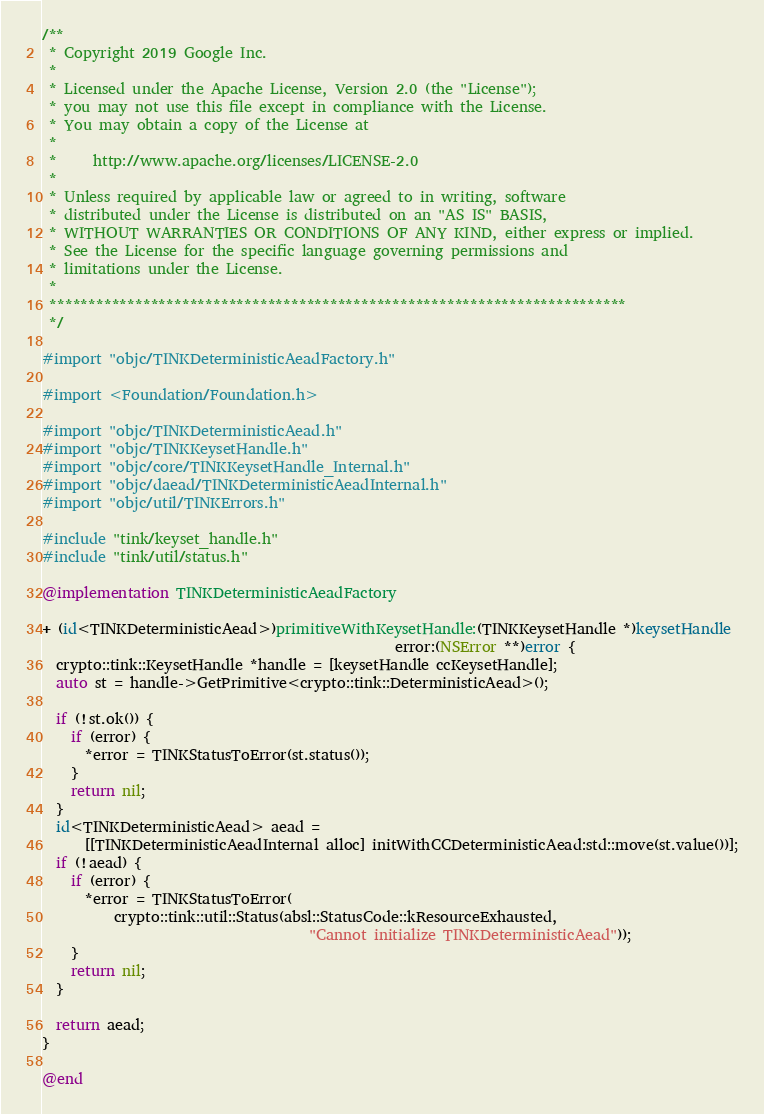Convert code to text. <code><loc_0><loc_0><loc_500><loc_500><_ObjectiveC_>/**
 * Copyright 2019 Google Inc.
 *
 * Licensed under the Apache License, Version 2.0 (the "License");
 * you may not use this file except in compliance with the License.
 * You may obtain a copy of the License at
 *
 *     http://www.apache.org/licenses/LICENSE-2.0
 *
 * Unless required by applicable law or agreed to in writing, software
 * distributed under the License is distributed on an "AS IS" BASIS,
 * WITHOUT WARRANTIES OR CONDITIONS OF ANY KIND, either express or implied.
 * See the License for the specific language governing permissions and
 * limitations under the License.
 *
 **************************************************************************
 */

#import "objc/TINKDeterministicAeadFactory.h"

#import <Foundation/Foundation.h>

#import "objc/TINKDeterministicAead.h"
#import "objc/TINKKeysetHandle.h"
#import "objc/core/TINKKeysetHandle_Internal.h"
#import "objc/daead/TINKDeterministicAeadInternal.h"
#import "objc/util/TINKErrors.h"

#include "tink/keyset_handle.h"
#include "tink/util/status.h"

@implementation TINKDeterministicAeadFactory

+ (id<TINKDeterministicAead>)primitiveWithKeysetHandle:(TINKKeysetHandle *)keysetHandle
                                                 error:(NSError **)error {
  crypto::tink::KeysetHandle *handle = [keysetHandle ccKeysetHandle];
  auto st = handle->GetPrimitive<crypto::tink::DeterministicAead>();

  if (!st.ok()) {
    if (error) {
      *error = TINKStatusToError(st.status());
    }
    return nil;
  }
  id<TINKDeterministicAead> aead =
      [[TINKDeterministicAeadInternal alloc] initWithCCDeterministicAead:std::move(st.value())];
  if (!aead) {
    if (error) {
      *error = TINKStatusToError(
          crypto::tink::util::Status(absl::StatusCode::kResourceExhausted,
                                     "Cannot initialize TINKDeterministicAead"));
    }
    return nil;
  }

  return aead;
}

@end
</code> 